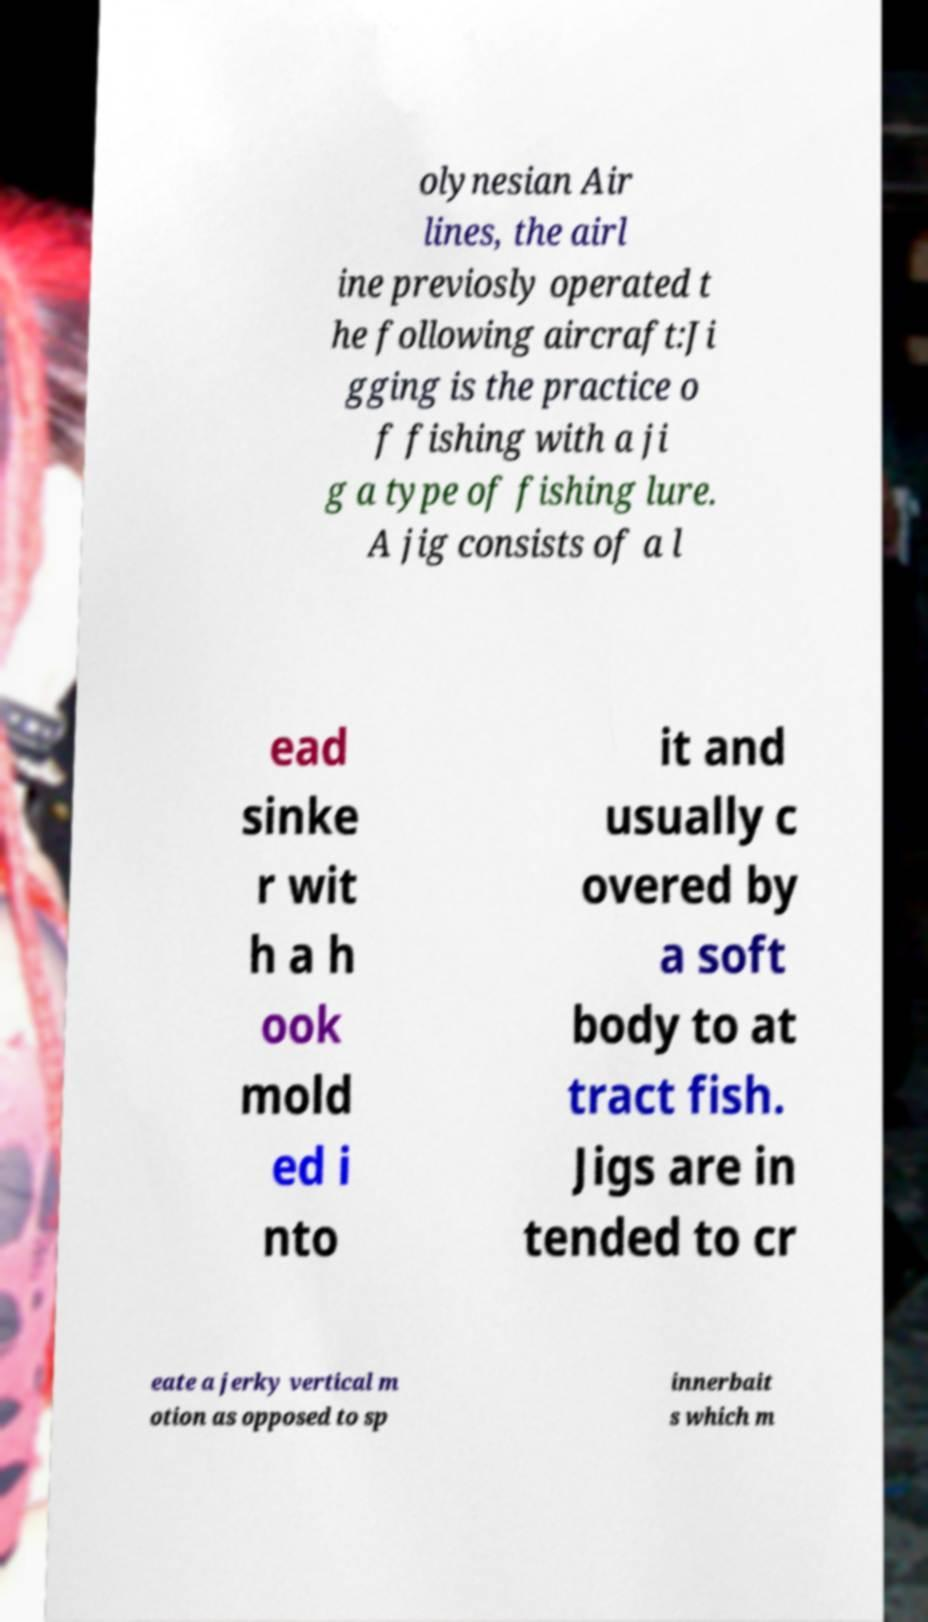There's text embedded in this image that I need extracted. Can you transcribe it verbatim? olynesian Air lines, the airl ine previosly operated t he following aircraft:Ji gging is the practice o f fishing with a ji g a type of fishing lure. A jig consists of a l ead sinke r wit h a h ook mold ed i nto it and usually c overed by a soft body to at tract fish. Jigs are in tended to cr eate a jerky vertical m otion as opposed to sp innerbait s which m 